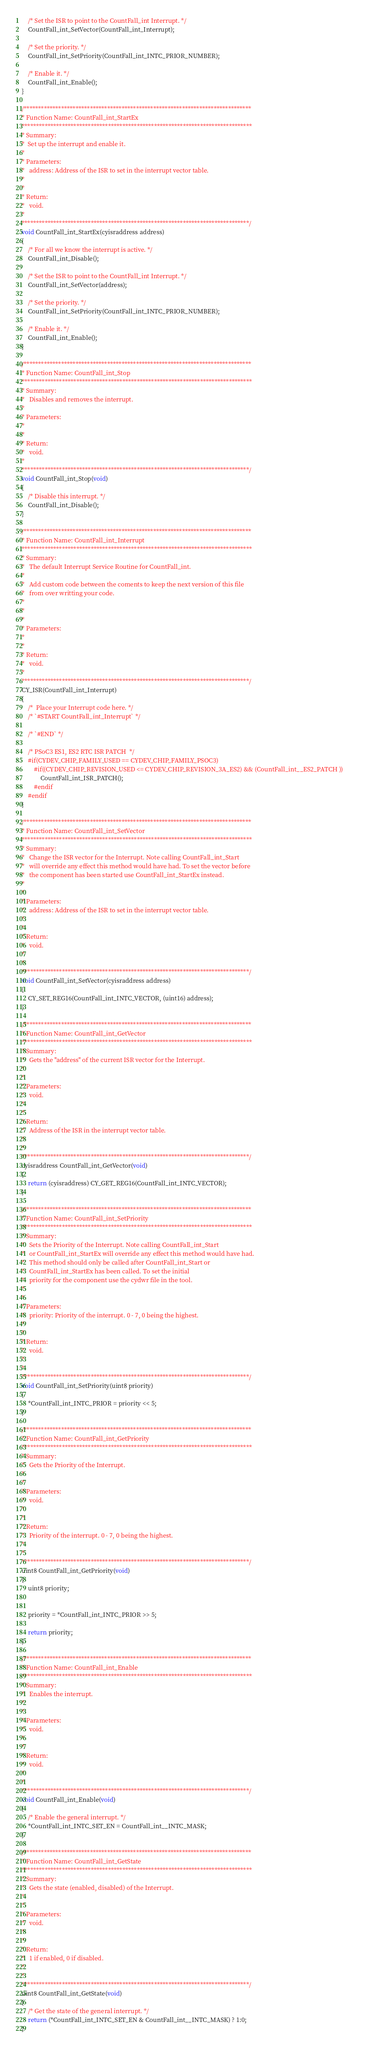<code> <loc_0><loc_0><loc_500><loc_500><_C_>    /* Set the ISR to point to the CountFall_int Interrupt. */
    CountFall_int_SetVector(CountFall_int_Interrupt);

    /* Set the priority. */
    CountFall_int_SetPriority(CountFall_int_INTC_PRIOR_NUMBER);

    /* Enable it. */
    CountFall_int_Enable();
}

/*******************************************************************************
* Function Name: CountFall_int_StartEx
********************************************************************************
* Summary:
*  Set up the interrupt and enable it.
*
* Parameters:  
*   address: Address of the ISR to set in the interrupt vector table.
*
*
* Return:
*   void.
*
*******************************************************************************/
void CountFall_int_StartEx(cyisraddress address)
{
    /* For all we know the interrupt is active. */
    CountFall_int_Disable();

    /* Set the ISR to point to the CountFall_int Interrupt. */
    CountFall_int_SetVector(address);

    /* Set the priority. */
    CountFall_int_SetPriority(CountFall_int_INTC_PRIOR_NUMBER);

    /* Enable it. */
    CountFall_int_Enable();
}

/*******************************************************************************
* Function Name: CountFall_int_Stop
********************************************************************************
* Summary:
*   Disables and removes the interrupt.
*
* Parameters:  
*
*
* Return:
*   void.
*
*******************************************************************************/
void CountFall_int_Stop(void) 
{
    /* Disable this interrupt. */
    CountFall_int_Disable();
}

/*******************************************************************************
* Function Name: CountFall_int_Interrupt
********************************************************************************
* Summary:
*   The default Interrupt Service Routine for CountFall_int.
*
*   Add custom code between the coments to keep the next version of this file
*   from over writting your code.
*
*
*
* Parameters:  
*
*
* Return:
*   void.
*
*******************************************************************************/
CY_ISR(CountFall_int_Interrupt)
{
    /*  Place your Interrupt code here. */
    /* `#START CountFall_int_Interrupt` */

    /* `#END` */

    /* PSoC3 ES1, ES2 RTC ISR PATCH  */ 
    #if(CYDEV_CHIP_FAMILY_USED == CYDEV_CHIP_FAMILY_PSOC3)
        #if((CYDEV_CHIP_REVISION_USED <= CYDEV_CHIP_REVISION_3A_ES2) && (CountFall_int__ES2_PATCH ))      
            CountFall_int_ISR_PATCH();
        #endif
    #endif
}

/*******************************************************************************
* Function Name: CountFall_int_SetVector
********************************************************************************
* Summary:
*   Change the ISR vector for the Interrupt. Note calling CountFall_int_Start
*   will override any effect this method would have had. To set the vector before
*   the component has been started use CountFall_int_StartEx instead.
*
*
* Parameters:
*   address: Address of the ISR to set in the interrupt vector table.
*
*
* Return:
*   void.
*
*
*******************************************************************************/
void CountFall_int_SetVector(cyisraddress address) 
{
    CY_SET_REG16(CountFall_int_INTC_VECTOR, (uint16) address);
}

/*******************************************************************************
* Function Name: CountFall_int_GetVector
********************************************************************************
* Summary:
*   Gets the "address" of the current ISR vector for the Interrupt.
*
*
* Parameters:
*   void.
*
*
* Return:
*   Address of the ISR in the interrupt vector table.
*
*
*******************************************************************************/
cyisraddress CountFall_int_GetVector(void) 
{
    return (cyisraddress) CY_GET_REG16(CountFall_int_INTC_VECTOR);
}

/*******************************************************************************
* Function Name: CountFall_int_SetPriority
********************************************************************************
* Summary:
*   Sets the Priority of the Interrupt. Note calling CountFall_int_Start
*   or CountFall_int_StartEx will override any effect this method would have had. 
*	This method should only be called after CountFall_int_Start or 
*	CountFall_int_StartEx has been called. To set the initial
*	priority for the component use the cydwr file in the tool.
*
*
* Parameters:
*   priority: Priority of the interrupt. 0 - 7, 0 being the highest.
*
*
* Return:
*   void.
*
*
*******************************************************************************/
void CountFall_int_SetPriority(uint8 priority) 
{
    *CountFall_int_INTC_PRIOR = priority << 5;
}

/*******************************************************************************
* Function Name: CountFall_int_GetPriority
********************************************************************************
* Summary:
*   Gets the Priority of the Interrupt.
*
*
* Parameters:
*   void.
*
*
* Return:
*   Priority of the interrupt. 0 - 7, 0 being the highest.
*
*
*******************************************************************************/
uint8 CountFall_int_GetPriority(void) 
{
    uint8 priority;


    priority = *CountFall_int_INTC_PRIOR >> 5;

    return priority;
}

/*******************************************************************************
* Function Name: CountFall_int_Enable
********************************************************************************
* Summary:
*   Enables the interrupt.
*
*
* Parameters:
*   void.
*
*
* Return:
*   void.
*
*
*******************************************************************************/
void CountFall_int_Enable(void) 
{
    /* Enable the general interrupt. */
    *CountFall_int_INTC_SET_EN = CountFall_int__INTC_MASK;
}

/*******************************************************************************
* Function Name: CountFall_int_GetState
********************************************************************************
* Summary:
*   Gets the state (enabled, disabled) of the Interrupt.
*
*
* Parameters:
*   void.
*
*
* Return:
*   1 if enabled, 0 if disabled.
*
*
*******************************************************************************/
uint8 CountFall_int_GetState(void) 
{
    /* Get the state of the general interrupt. */
    return (*CountFall_int_INTC_SET_EN & CountFall_int__INTC_MASK) ? 1:0;
}
</code> 